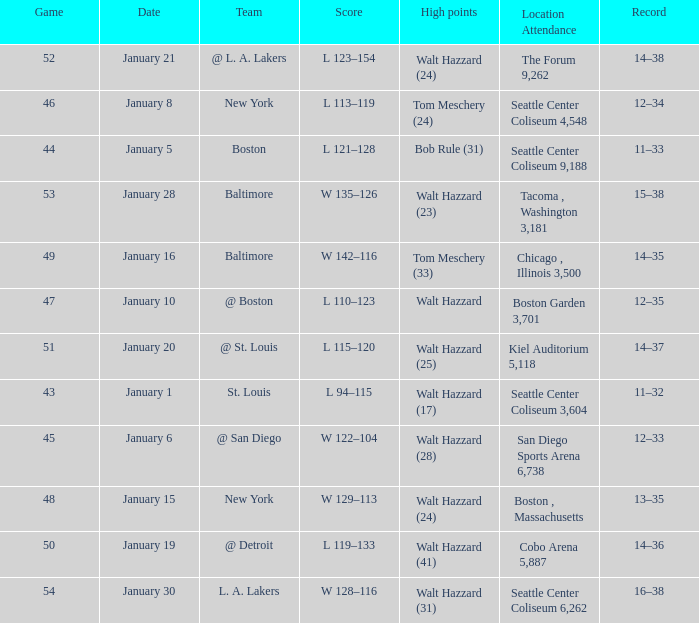What is the st. louis squad's record high achievement? 11–32. 